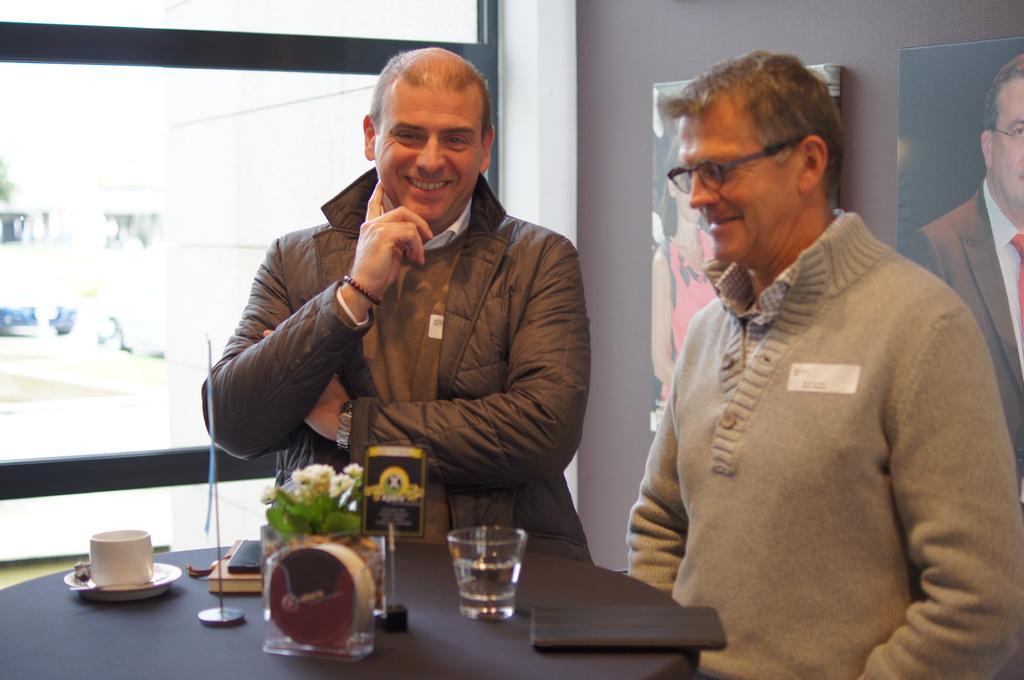Could you give a brief overview of what you see in this image? In the foreground of the picture there is a table, on the table there is a glass, house plant, a flag, a book and cups. In the center of the image there are two men standing and smiling. On the top right there are frames on the wall. In the top right the wall is painted in brown. On the left there is a glass window. 